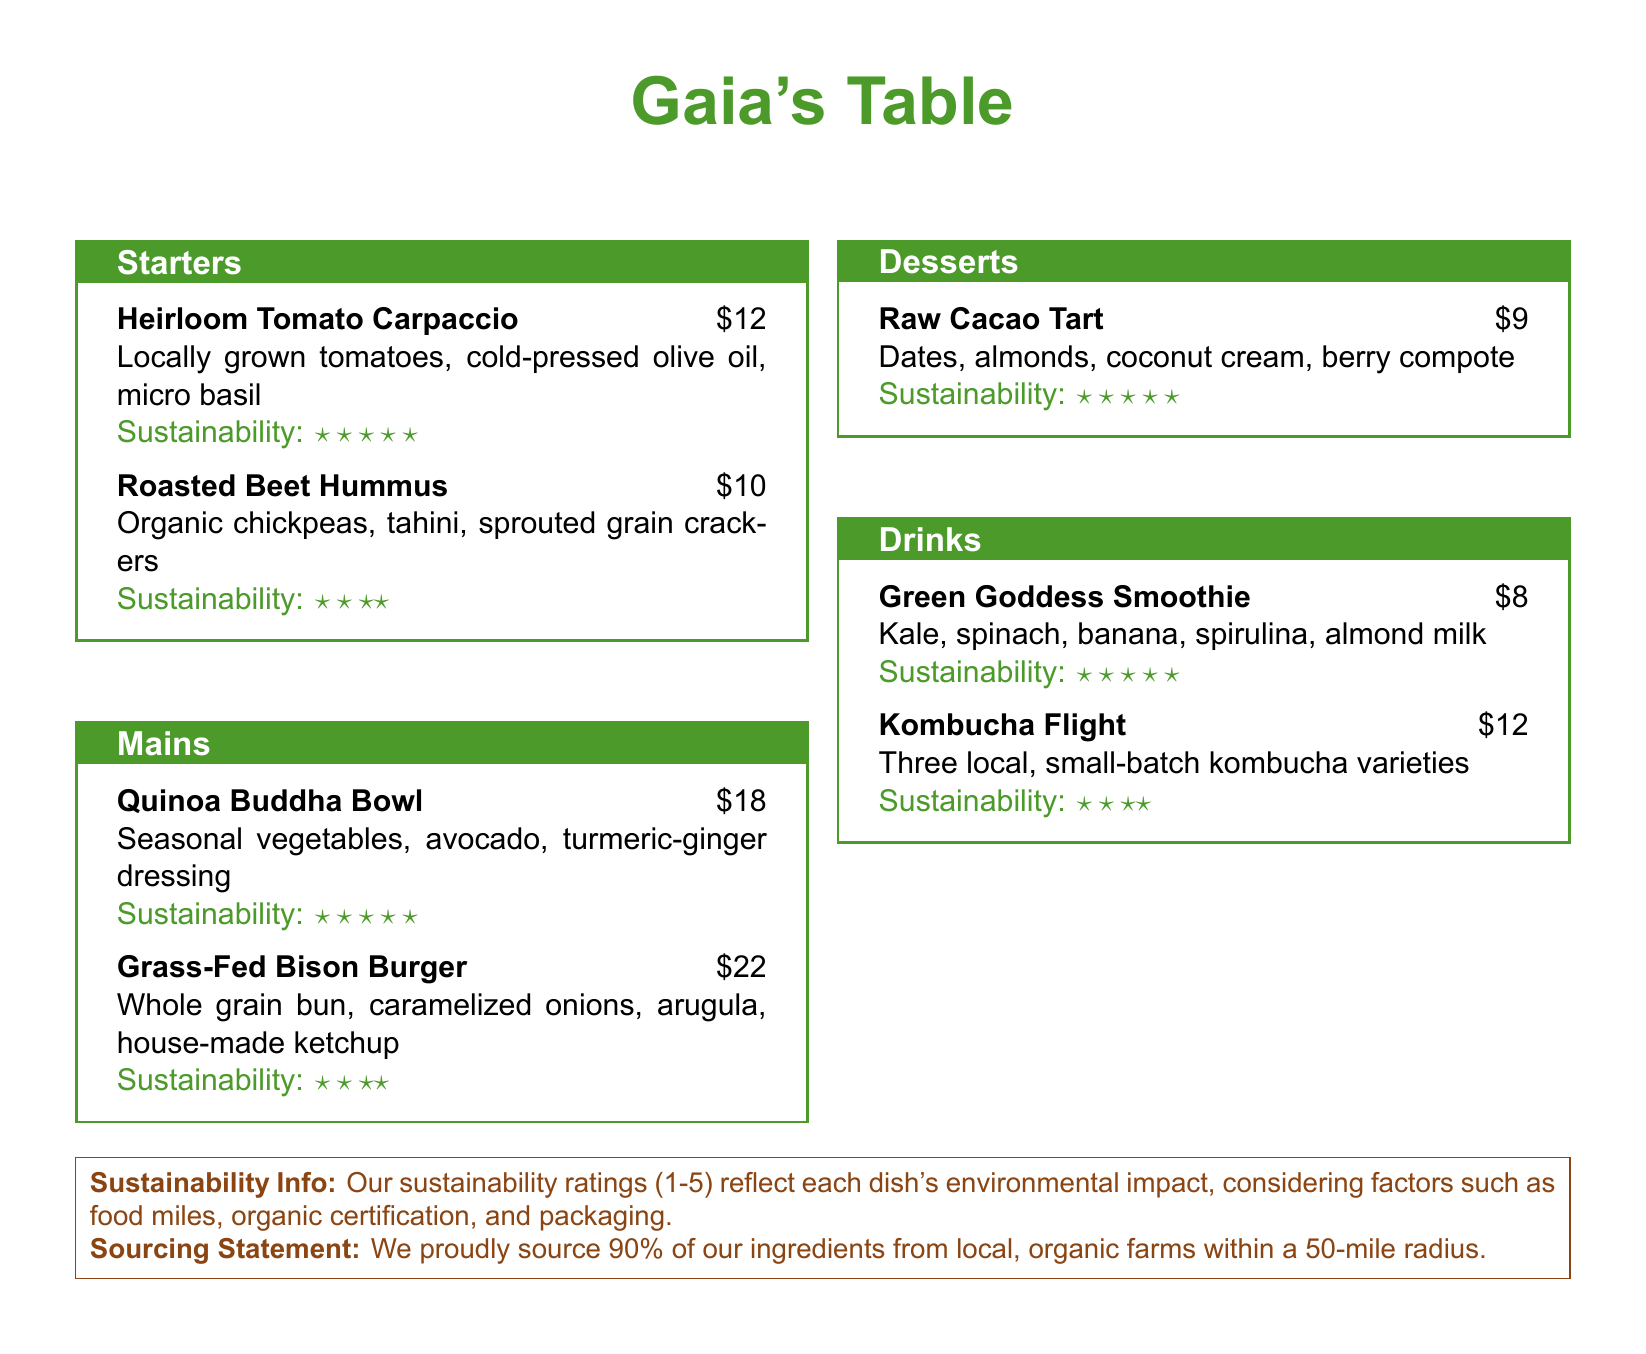what is the name of the restaurant? The name of the restaurant is prominently displayed at the top of the menu.
Answer: Gaia's Table how much does the Heirloom Tomato Carpaccio cost? The price of the Heirloom Tomato Carpaccio is listed next to its name on the menu.
Answer: $12 what are the main ingredients in the Quinoa Buddha Bowl? The ingredients for the Quinoa Buddha Bowl are specified in the description on the menu.
Answer: Seasonal vegetables, avocado, turmeric-ginger dressing what sustainability rating does the Raw Cacao Tart have? The sustainability rating for the Raw Cacao Tart is provided in the dish's description.
Answer: ★★★★★ which section lists the Green Goddess Smoothie? The section containing the Green Goddess Smoothie can be identified by its title.
Answer: Drinks if a dish has a sustainability rating of three stars, what does it indicate? The sustainability info section explains what the ratings reflect about the dish's environmental impact.
Answer: Environmental impact how much of the restaurant's ingredients come from local farms? The sourcing statement provides specific information about the percentage of ingredients sourced locally.
Answer: 90% which dish has the highest price on the menu? By comparing the prices of all dishes listed, one can determine the highest priced item.
Answer: Grass-Fed Bison Burger how many local kombucha varieties are featured in the Kombucha Flight? The description under the Kombucha Flight indicates the number of varieties included.
Answer: Three 